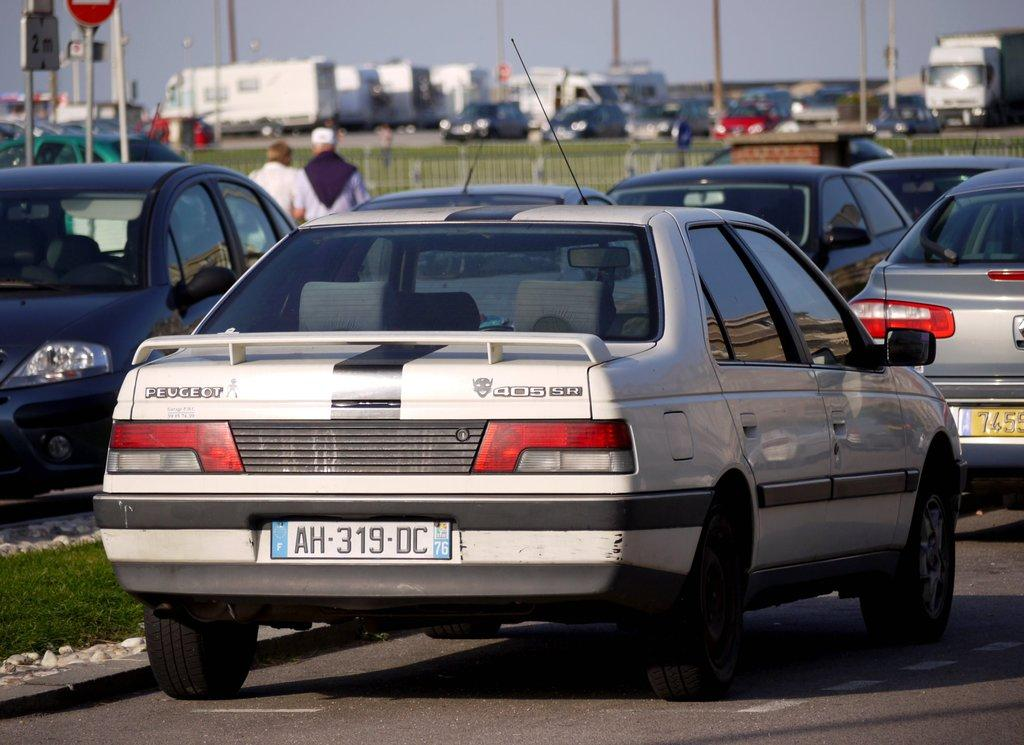What can be seen on the road in the image? There are cars on the road in the image. What type of vegetation is visible in the image? There is grass visible in the image. What structures can be seen in the image? There is a fence and poles visible in the image. What type of information might be conveyed by the signboard in the image? The signboard in the image might convey information about directions, warnings, or advertisements. How many people are present in the image? There are two people in the image. What else can be seen in the background of the image? There are vehicles and the sky visible in the background of the image. Where are the kittens playing in the image? There are no kittens present in the image. How many bottles can be seen in the image? There are no bottles visible in the image. 